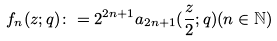Convert formula to latex. <formula><loc_0><loc_0><loc_500><loc_500>f _ { n } ( z ; q ) \colon = 2 ^ { 2 n + 1 } a _ { 2 n + 1 } ( \frac { z } { 2 } ; q ) ( n \in \mathbb { N } )</formula> 